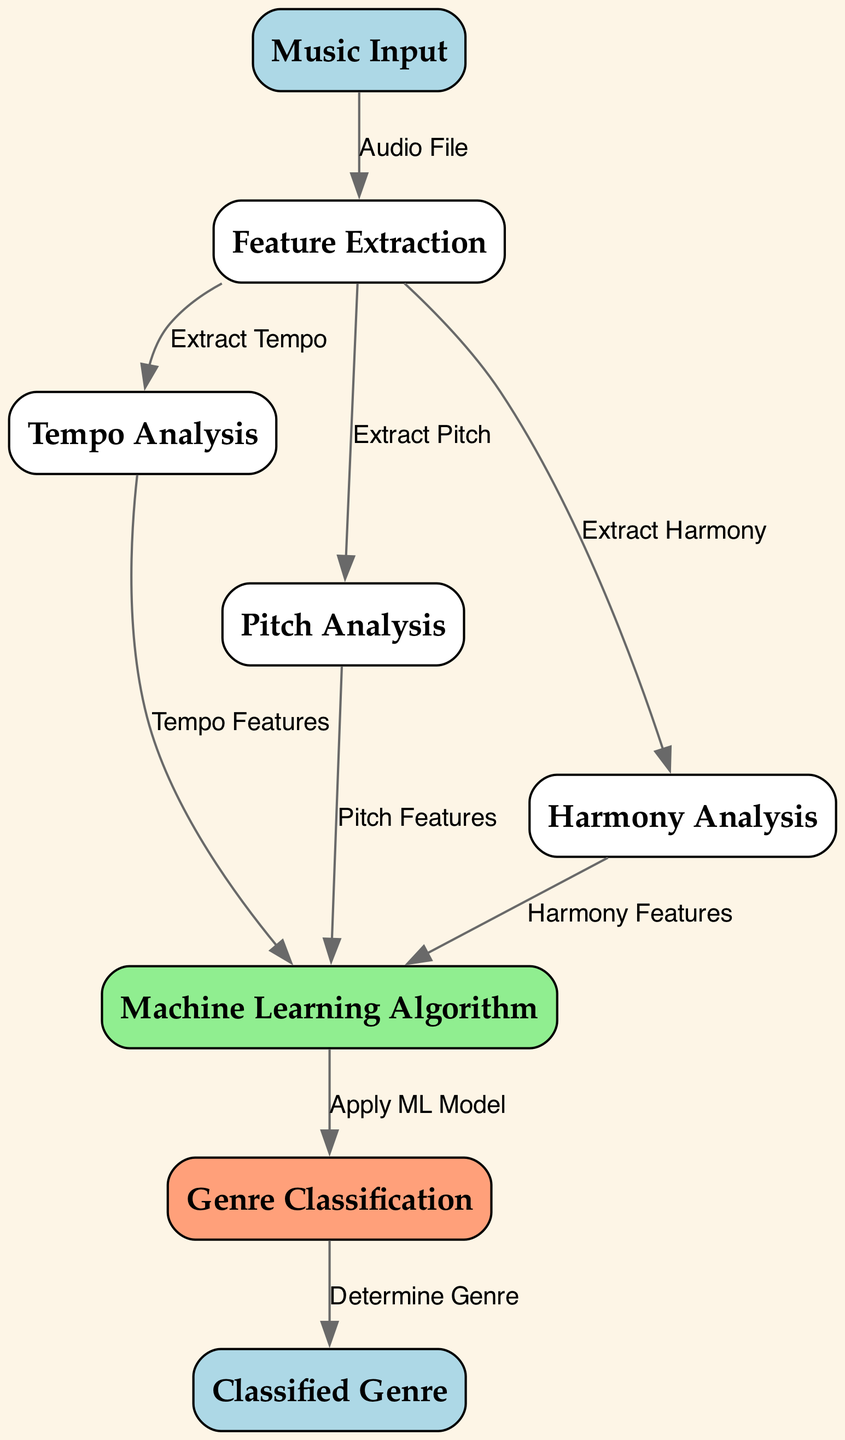What is the first step in the diagram? The first step in the diagram is the 'Music Input' node, which represents the initial audio file provided for analysis.
Answer: Music Input How many features are extracted in the feature extraction step? The diagram shows three features being extracted: Tempo, Pitch, and Harmony, indicating that a total of three features are processed.
Answer: Three Which node applies the machine learning model? The 'Machine Learning Algorithm' node is responsible for applying the machine learning model on the extracted features to facilitate genre classification.
Answer: Machine Learning Algorithm What are the inputs to the 'Machine Learning Algorithm' node? The inputs to the 'Machine Learning Algorithm' node are the output features from Tempo Analysis, Pitch Analysis, and Harmony Analysis, which are combined for processing.
Answer: Tempo Features, Pitch Features, Harmony Features What does the 'Genre Classification' node determine? The 'Genre Classification' node determines the genre based on the processed features from the machine learning algorithm, marking the output phase of genre identification.
Answer: Determine Genre What type of input does the diagram start with? The diagram starts with an 'Audio File' as the input for the classification process, which is processed further down the flow.
Answer: Audio File Explain how the Tempo, Pitch, and Harmony features connect to the next stage. Tempo, Pitch, and Harmony features each provide their respective data as inputs to the 'Machine Learning Algorithm' node, indicating that all three features are necessary for a holistic analysis.
Answer: Connects to Machine Learning Algorithm What is the final output of the diagram? The final output of the diagram is the 'Classified Genre', which presents the result of the genre classification process based on the preceding analyses and algorithms.
Answer: Classified Genre 